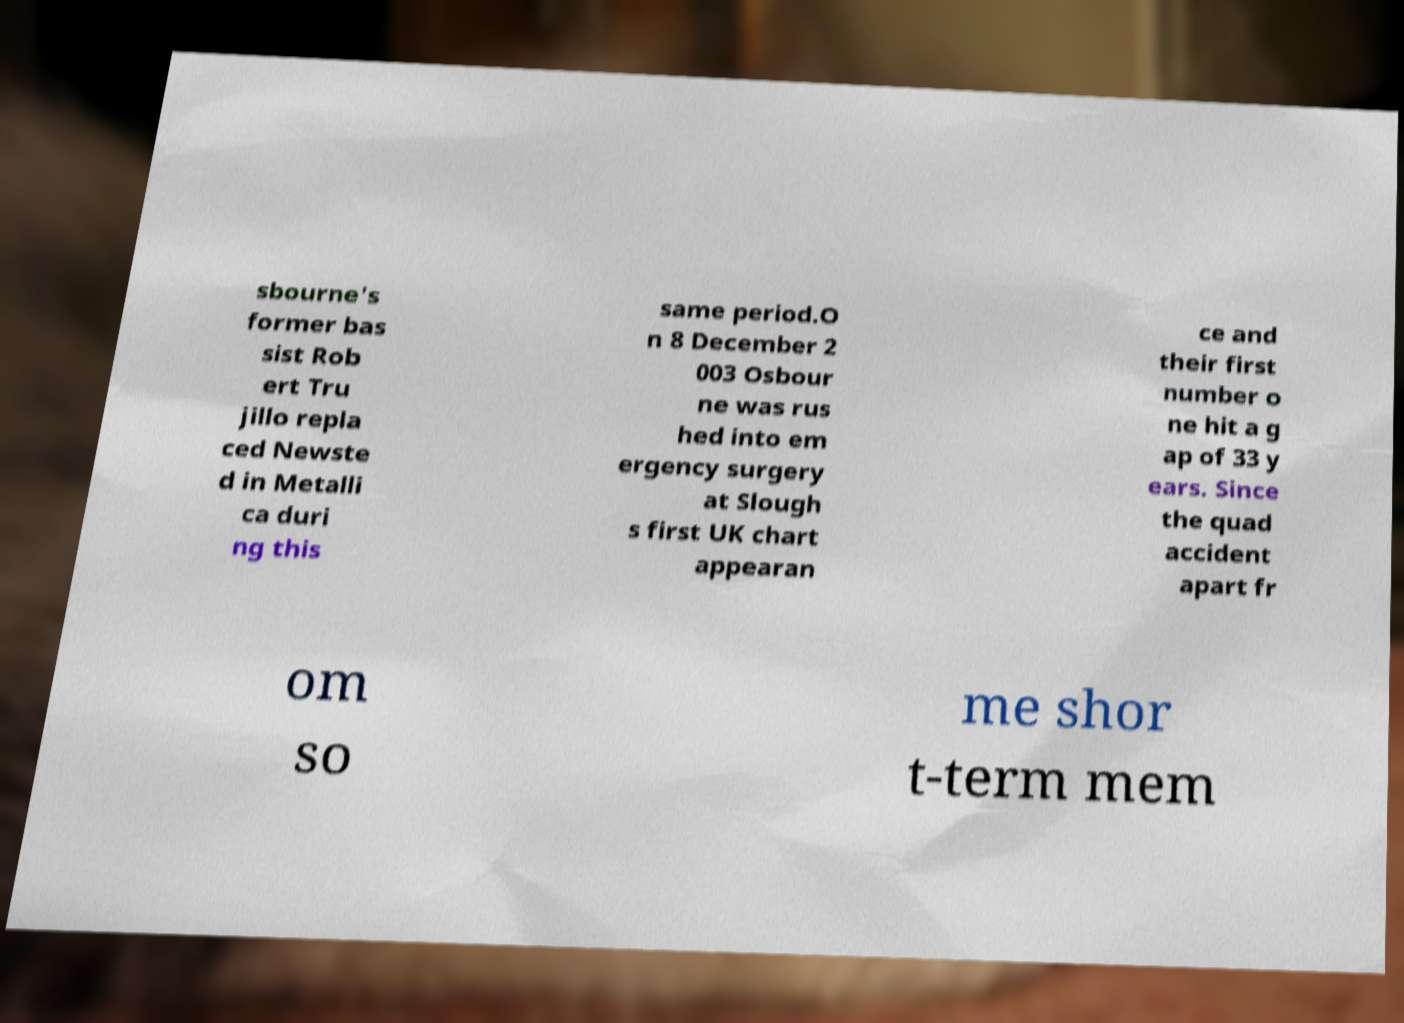I need the written content from this picture converted into text. Can you do that? sbourne's former bas sist Rob ert Tru jillo repla ced Newste d in Metalli ca duri ng this same period.O n 8 December 2 003 Osbour ne was rus hed into em ergency surgery at Slough s first UK chart appearan ce and their first number o ne hit a g ap of 33 y ears. Since the quad accident apart fr om so me shor t-term mem 